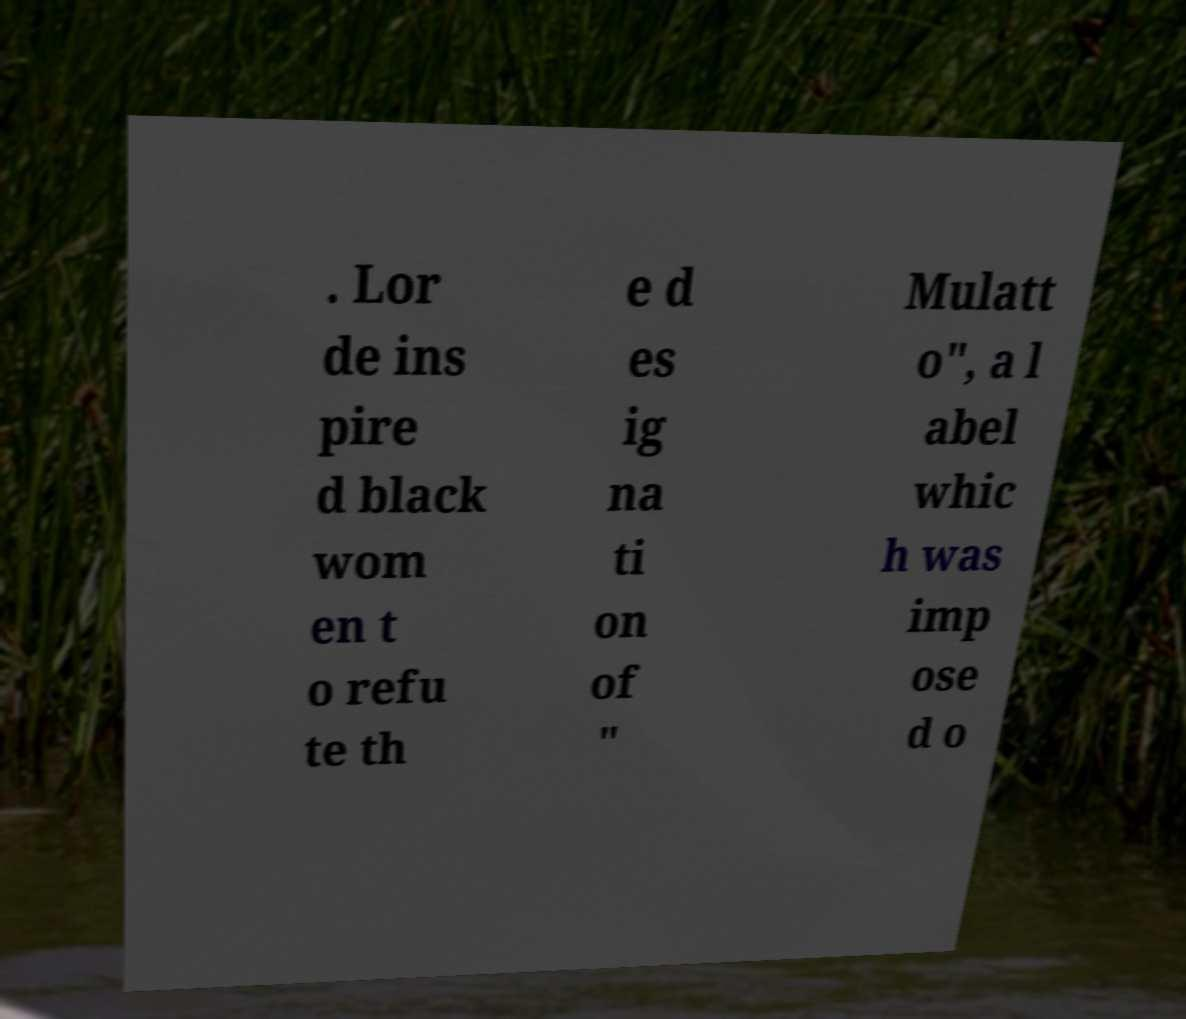What messages or text are displayed in this image? I need them in a readable, typed format. . Lor de ins pire d black wom en t o refu te th e d es ig na ti on of " Mulatt o", a l abel whic h was imp ose d o 